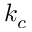<formula> <loc_0><loc_0><loc_500><loc_500>k _ { c }</formula> 